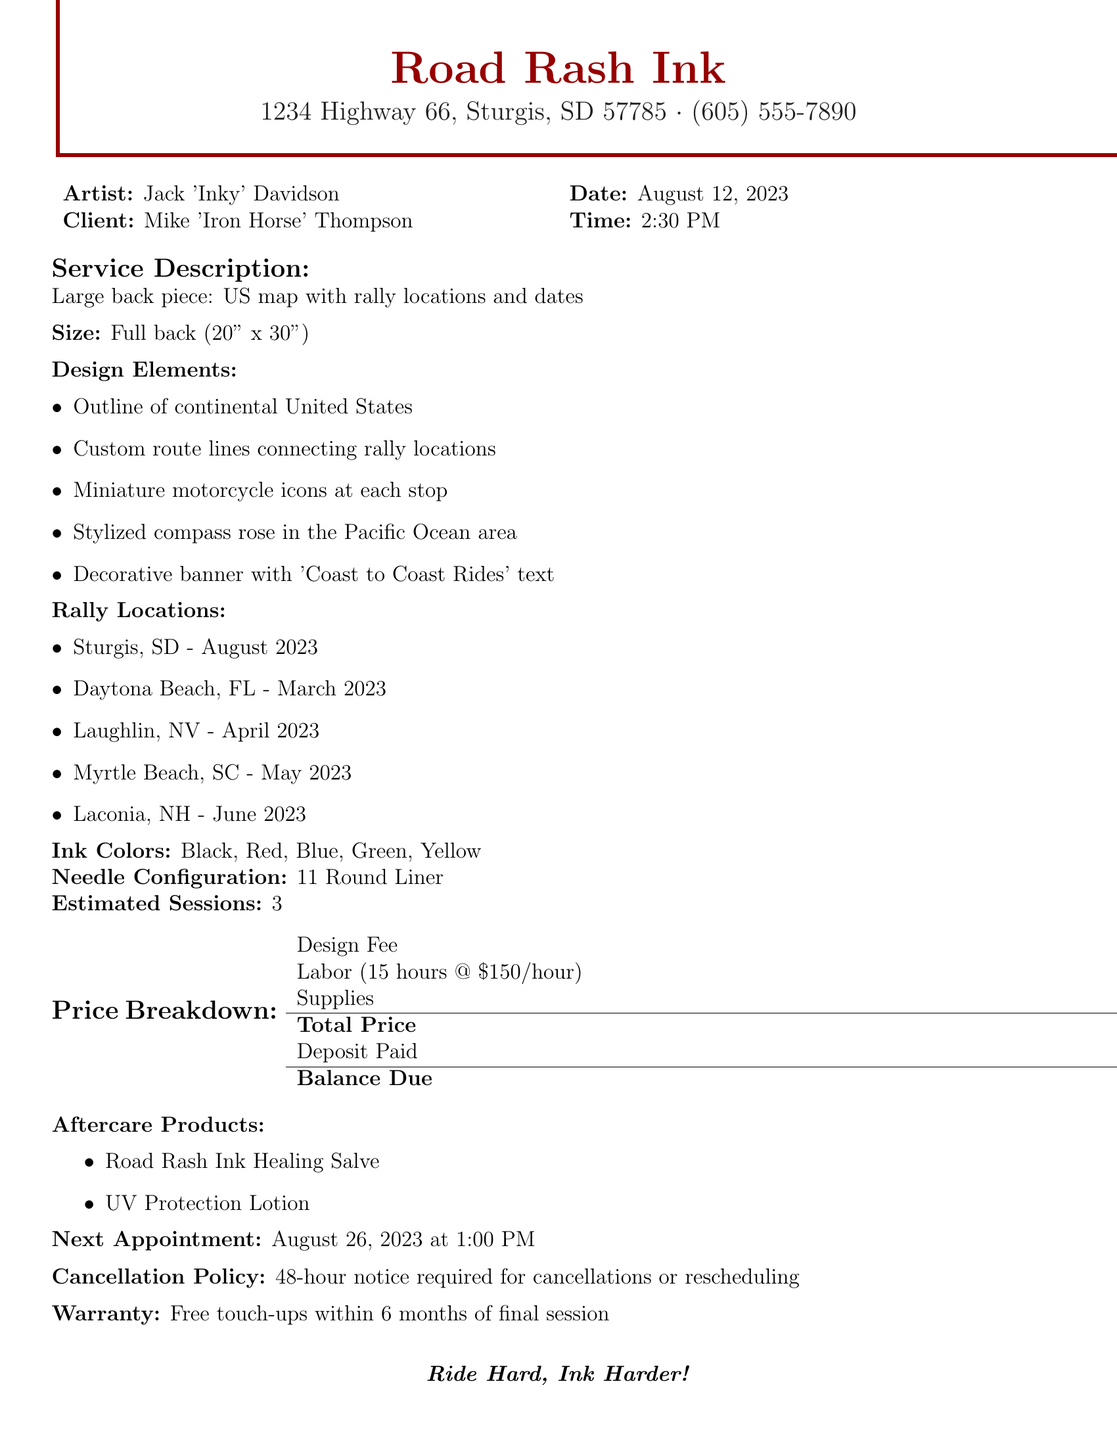What is the tattoo parlor's name? The tattoo parlor's name is stated clearly at the top of the document.
Answer: Road Rash Ink Who is the tattoo artist? The artist's name is specified in the document under the artist information section.
Answer: Jack 'Inky' Davidson What is the total price of the tattoo? The total price is listed in the price breakdown section of the document.
Answer: 2600 What is the size of the tattoo? The size of the back piece is mentioned right after the service description.
Answer: Full back (20" x 30") How many estimated sessions are required for the tattoo? The number of estimated sessions is indicated in the document, under estimated sessions.
Answer: 3 What is the balance due after the deposit? The balance due is stated in the price breakdown section after the total price.
Answer: 2100 What are the colors of ink used for the tattoo? The ink colors are listed right after the needle configuration in the document.
Answer: Black, Red, Blue, Green, Yellow What is the cancellation policy? The cancellation policy is described toward the end of the document.
Answer: 48-hour notice required for cancellations or rescheduling What is the next appointment date and time? The next appointment date and time is mentioned in the aftercare section of the document.
Answer: August 26, 2023 at 1:00 PM 